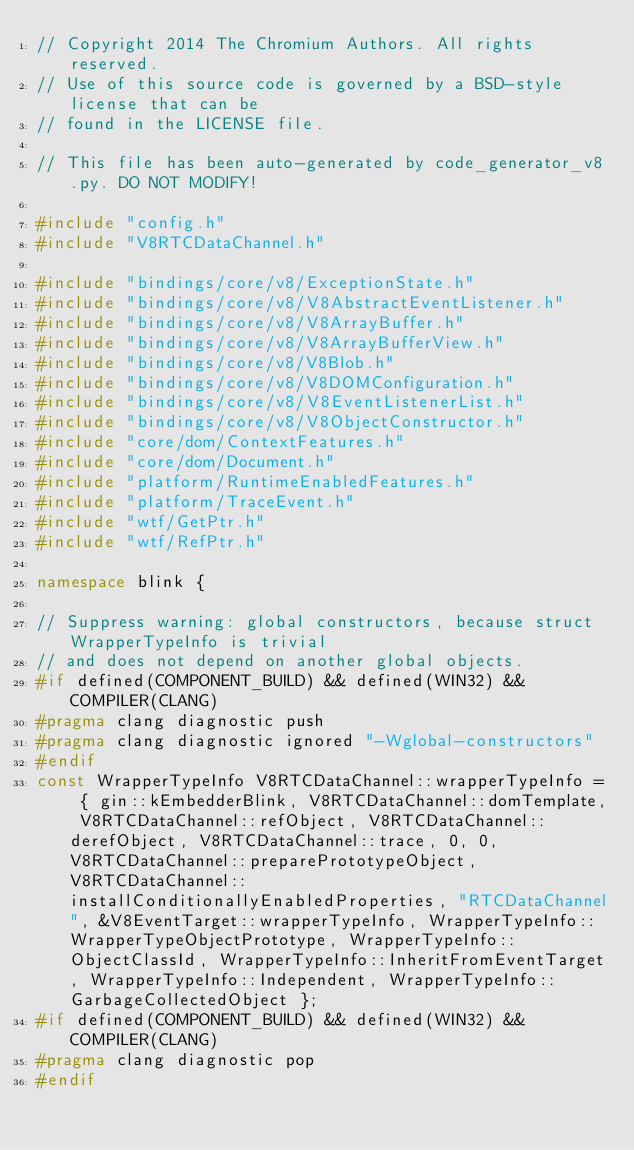<code> <loc_0><loc_0><loc_500><loc_500><_C++_>// Copyright 2014 The Chromium Authors. All rights reserved.
// Use of this source code is governed by a BSD-style license that can be
// found in the LICENSE file.

// This file has been auto-generated by code_generator_v8.py. DO NOT MODIFY!

#include "config.h"
#include "V8RTCDataChannel.h"

#include "bindings/core/v8/ExceptionState.h"
#include "bindings/core/v8/V8AbstractEventListener.h"
#include "bindings/core/v8/V8ArrayBuffer.h"
#include "bindings/core/v8/V8ArrayBufferView.h"
#include "bindings/core/v8/V8Blob.h"
#include "bindings/core/v8/V8DOMConfiguration.h"
#include "bindings/core/v8/V8EventListenerList.h"
#include "bindings/core/v8/V8ObjectConstructor.h"
#include "core/dom/ContextFeatures.h"
#include "core/dom/Document.h"
#include "platform/RuntimeEnabledFeatures.h"
#include "platform/TraceEvent.h"
#include "wtf/GetPtr.h"
#include "wtf/RefPtr.h"

namespace blink {

// Suppress warning: global constructors, because struct WrapperTypeInfo is trivial
// and does not depend on another global objects.
#if defined(COMPONENT_BUILD) && defined(WIN32) && COMPILER(CLANG)
#pragma clang diagnostic push
#pragma clang diagnostic ignored "-Wglobal-constructors"
#endif
const WrapperTypeInfo V8RTCDataChannel::wrapperTypeInfo = { gin::kEmbedderBlink, V8RTCDataChannel::domTemplate, V8RTCDataChannel::refObject, V8RTCDataChannel::derefObject, V8RTCDataChannel::trace, 0, 0, V8RTCDataChannel::preparePrototypeObject, V8RTCDataChannel::installConditionallyEnabledProperties, "RTCDataChannel", &V8EventTarget::wrapperTypeInfo, WrapperTypeInfo::WrapperTypeObjectPrototype, WrapperTypeInfo::ObjectClassId, WrapperTypeInfo::InheritFromEventTarget, WrapperTypeInfo::Independent, WrapperTypeInfo::GarbageCollectedObject };
#if defined(COMPONENT_BUILD) && defined(WIN32) && COMPILER(CLANG)
#pragma clang diagnostic pop
#endif
</code> 